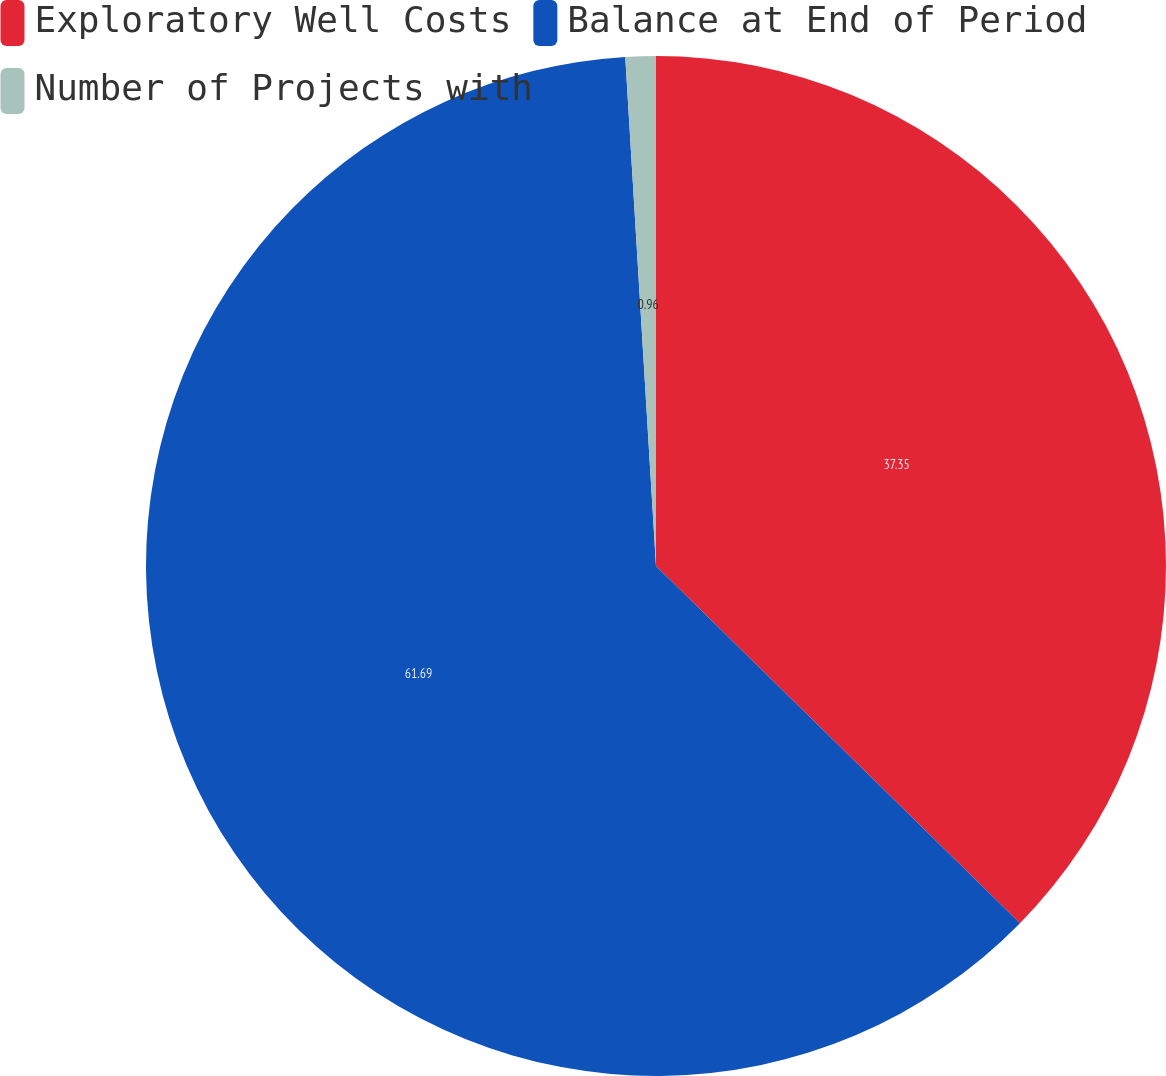Convert chart to OTSL. <chart><loc_0><loc_0><loc_500><loc_500><pie_chart><fcel>Exploratory Well Costs<fcel>Balance at End of Period<fcel>Number of Projects with<nl><fcel>37.35%<fcel>61.69%<fcel>0.96%<nl></chart> 